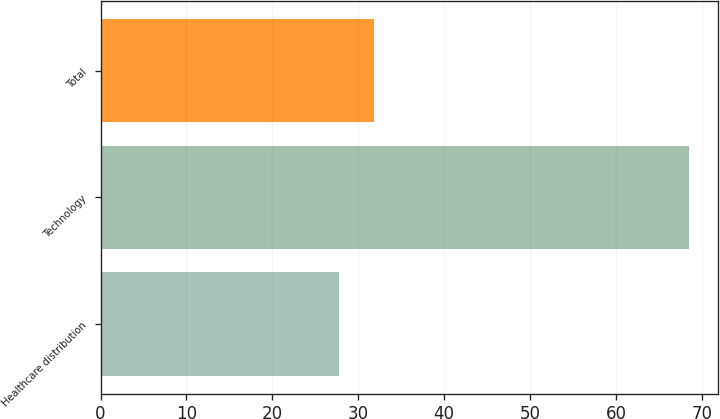Convert chart. <chart><loc_0><loc_0><loc_500><loc_500><bar_chart><fcel>Healthcare distribution<fcel>Technology<fcel>Total<nl><fcel>27.8<fcel>68.5<fcel>31.87<nl></chart> 